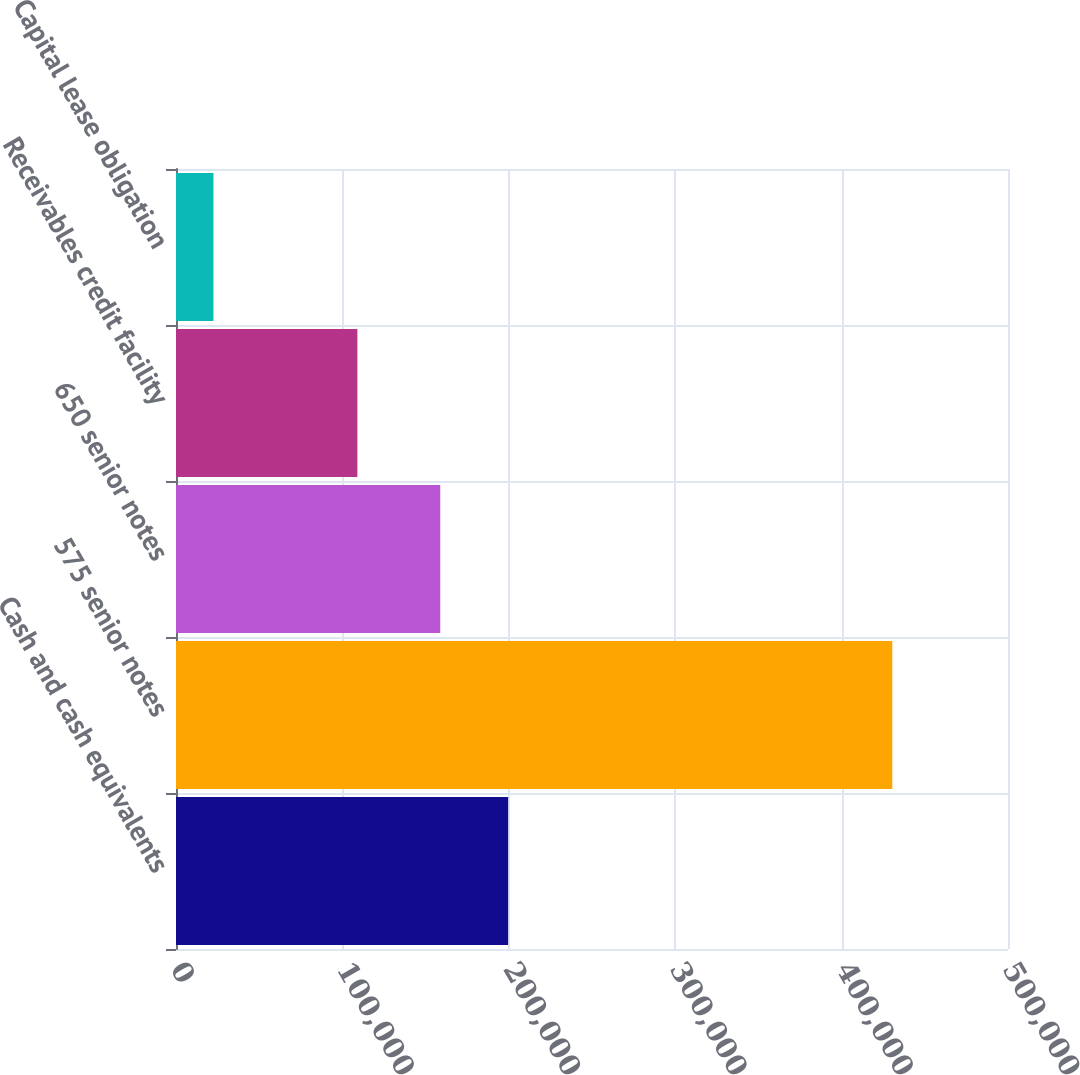Convert chart. <chart><loc_0><loc_0><loc_500><loc_500><bar_chart><fcel>Cash and cash equivalents<fcel>575 senior notes<fcel>650 senior notes<fcel>Receivables credit facility<fcel>Capital lease obligation<nl><fcel>199596<fcel>430464<fcel>158800<fcel>109000<fcel>22502<nl></chart> 